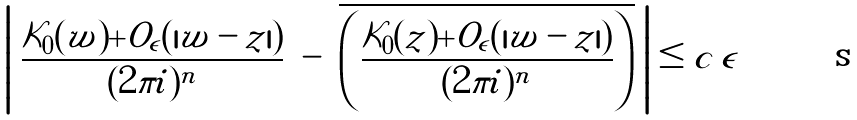Convert formula to latex. <formula><loc_0><loc_0><loc_500><loc_500>\left | \ \frac { \mathcal { K } _ { 0 } ( w ) + O _ { \epsilon } ( | w - z | ) } { ( 2 \pi i ) ^ { n } } \ - \ \overline { \left ( \frac { { \mathcal { K } _ { 0 } } ( z ) + { O _ { \epsilon } } ( | w - z | ) } { ( 2 \pi i ) ^ { n } } \right ) } \ \right | \leq c \, \epsilon</formula> 